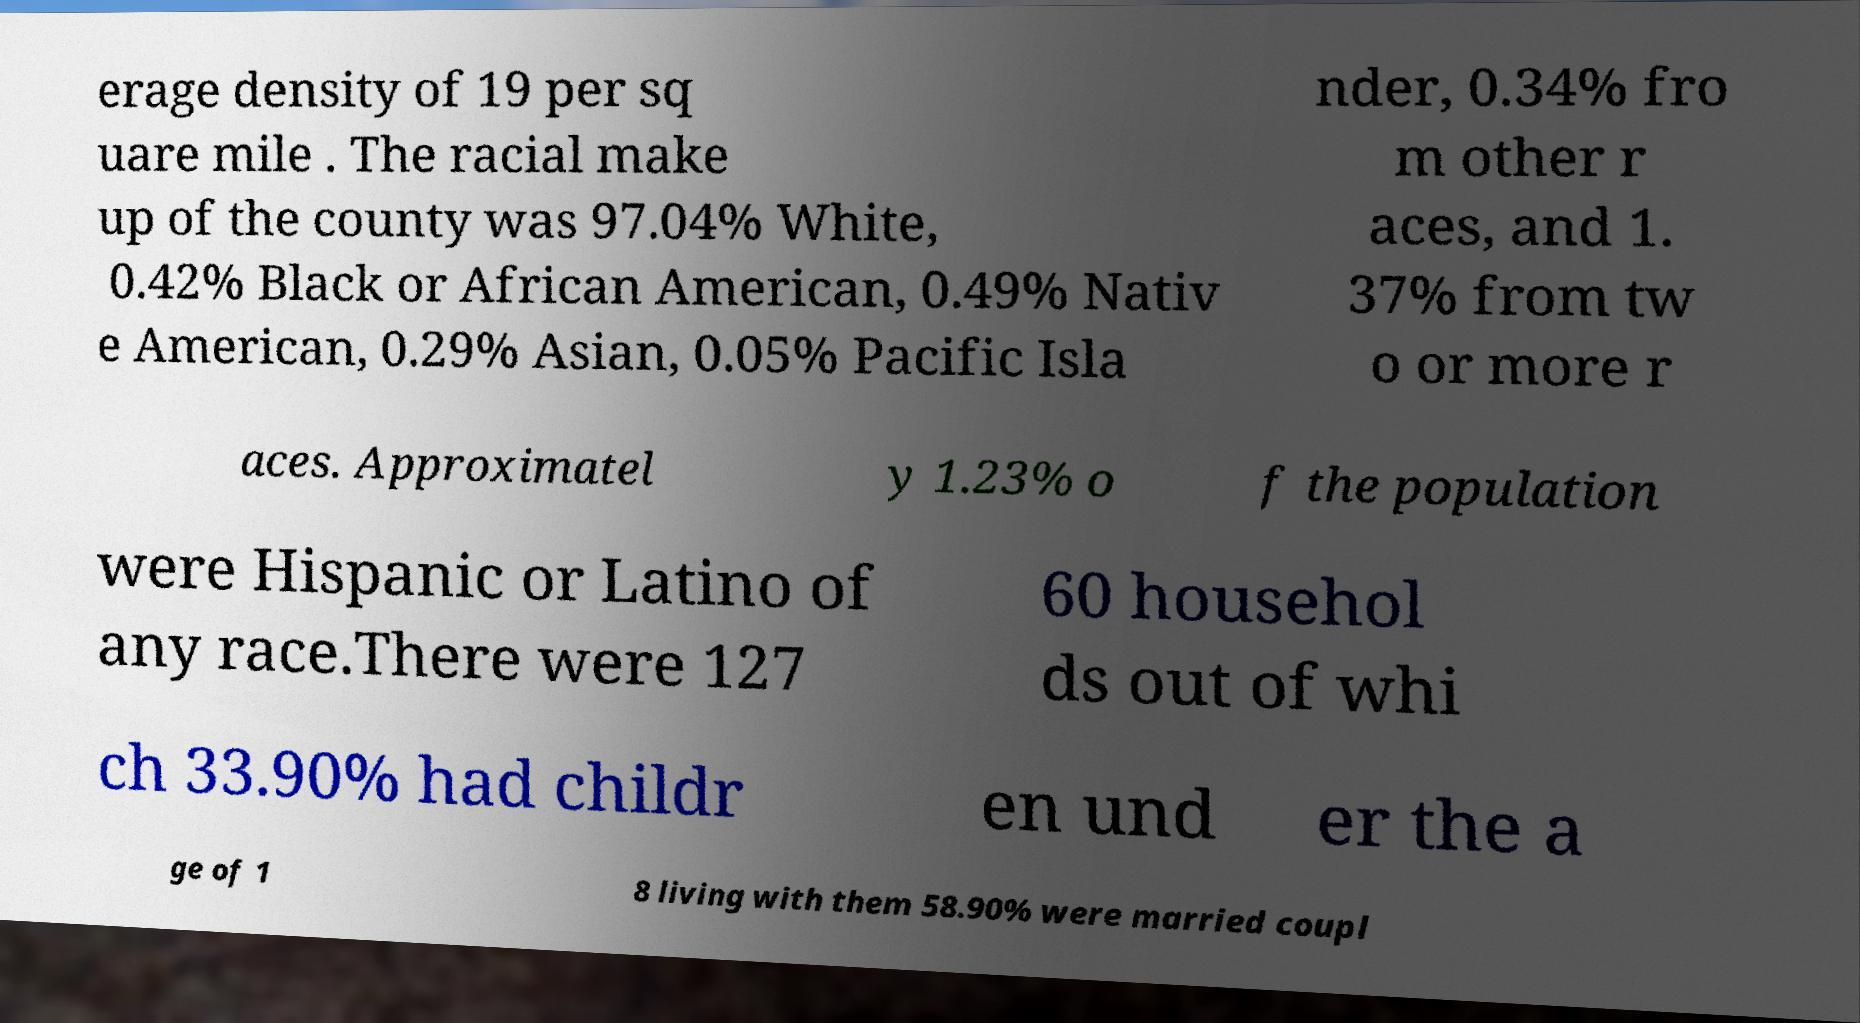Can you read and provide the text displayed in the image?This photo seems to have some interesting text. Can you extract and type it out for me? erage density of 19 per sq uare mile . The racial make up of the county was 97.04% White, 0.42% Black or African American, 0.49% Nativ e American, 0.29% Asian, 0.05% Pacific Isla nder, 0.34% fro m other r aces, and 1. 37% from tw o or more r aces. Approximatel y 1.23% o f the population were Hispanic or Latino of any race.There were 127 60 househol ds out of whi ch 33.90% had childr en und er the a ge of 1 8 living with them 58.90% were married coupl 